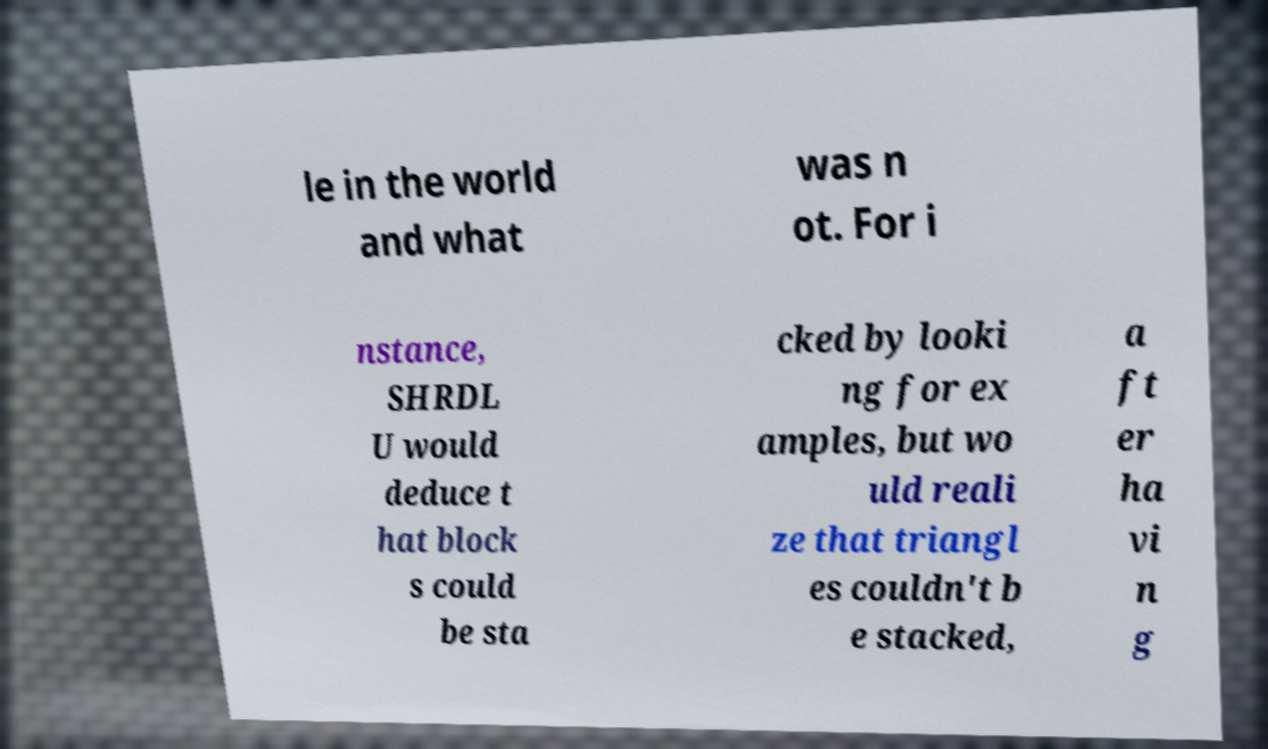Could you extract and type out the text from this image? le in the world and what was n ot. For i nstance, SHRDL U would deduce t hat block s could be sta cked by looki ng for ex amples, but wo uld reali ze that triangl es couldn't b e stacked, a ft er ha vi n g 